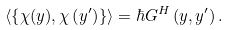Convert formula to latex. <formula><loc_0><loc_0><loc_500><loc_500>\left \langle \left \{ \chi ( y ) , \chi \left ( y ^ { \prime } \right ) \right \} \right \rangle = \hbar { G } ^ { H } \left ( y , y ^ { \prime } \right ) .</formula> 